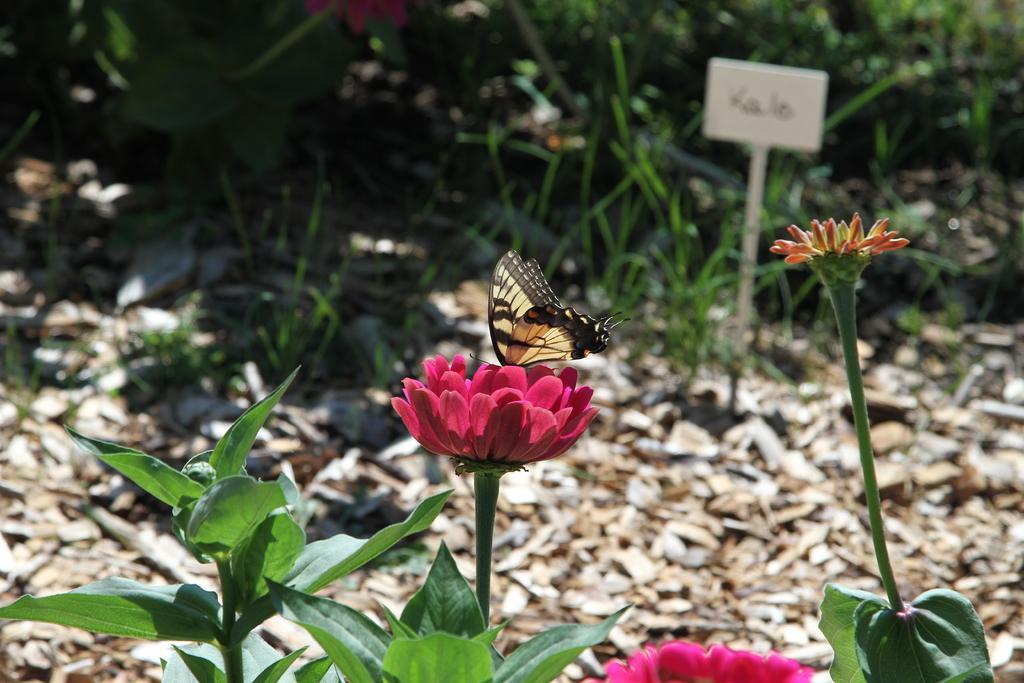Describe this image in one or two sentences. Front we can see plants with flowers. On this flower there is a butterfly. Background it is blurry, we can see a board, grass and plants. 